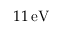<formula> <loc_0><loc_0><loc_500><loc_500>1 1 \, e V</formula> 